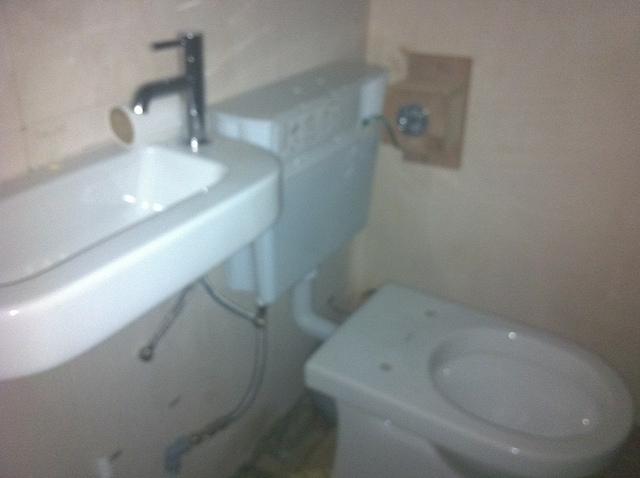Is this a new bathroom?
Keep it brief. No. Is there a mirror?
Concise answer only. No. Is this bathroom clean?
Short answer required. Yes. Is there a toilet seat on the toilet?
Short answer required. No. 